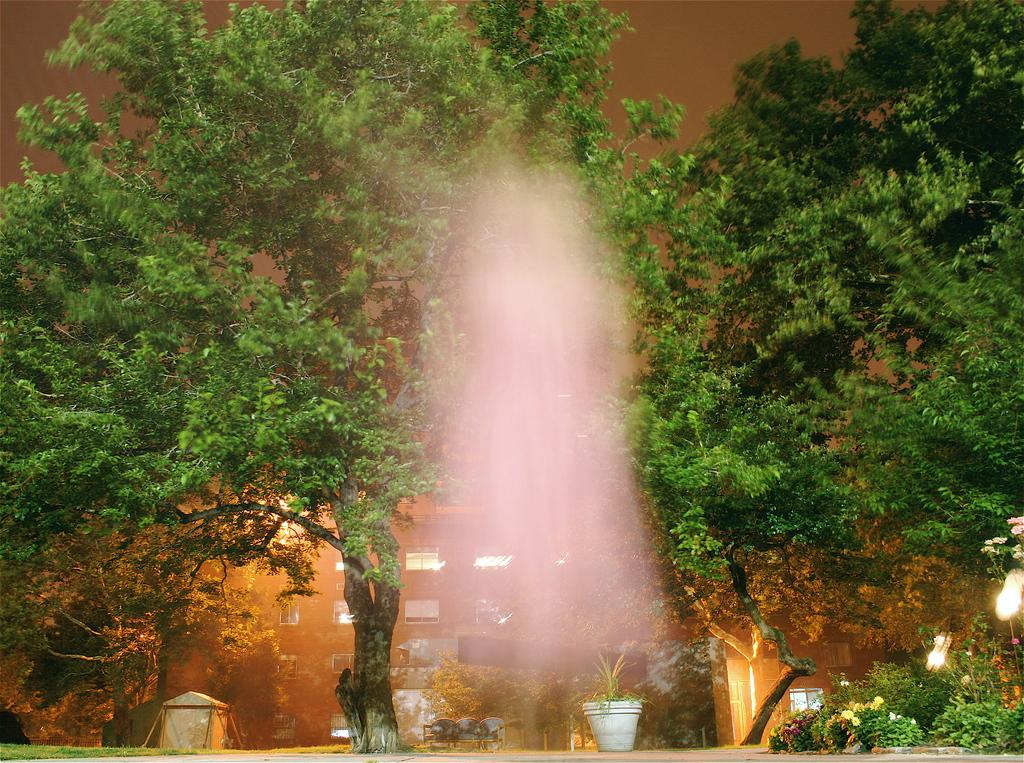What is the main feature in the image? There is a fountain in the image. What type of vegetation can be seen in the image? There are plants with flowers and a plant in a pot in the image. What type of structure is present in the image? There is a tent and a building with windows in the image. What type of lighting is present in the image? There are lights in the image. What type of natural environment is visible in the image? There is a group of trees in the image. What part of the natural environment is visible in the image? The sky is visible in the image. What type of punishment is being administered to the spiders in the image? There are no spiders present in the image, so no punishment is being administered. 